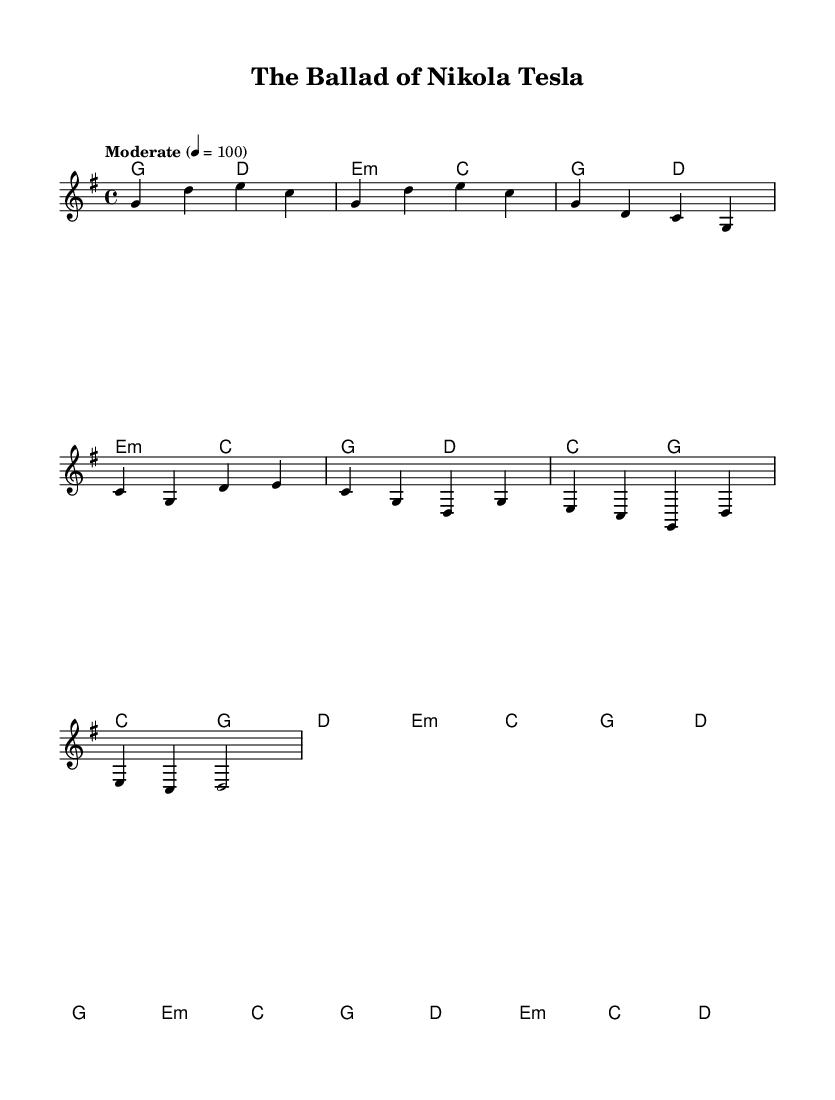What is the key signature of this music? The key signature is G major, which has one sharp (F#). This can be identified by looking at the key signature placed at the beginning of the staff.
Answer: G major What is the time signature of this music? The time signature is 4/4, which means there are four beats in each measure. This is noted at the beginning of the score where the numbers appear as a fraction.
Answer: 4/4 What is the tempo marking of this music? The tempo marking indicates "Moderate" at a speed of 100 beats per minute. This information is usually placed above the staff early in the sheet music.
Answer: Moderate, 100 How many measures are in the chorus section? The chorus section consists of four measures, which can be determined by counting the vertical lines (bar lines) that separate groups of notes in that section of the music.
Answer: 4 What chord is introduced in the intro? The chord introduced in the intro is G major; this can be found in the chord symbols listed above the melody during the intro measures.
Answer: G major Which historical figure does this song reference? The song references Nikola Tesla, which can be deduced from the title listed at the beginning of the score.
Answer: Nikola Tesla What is the emotional tone suggested by the melody in the bridge? The emotional tone suggested is reflective, as indicated by the choice of notes and their progression during the bridge section. This is inferred by analyzing the notes and harmonies that give a sense of contemplation.
Answer: Reflective 